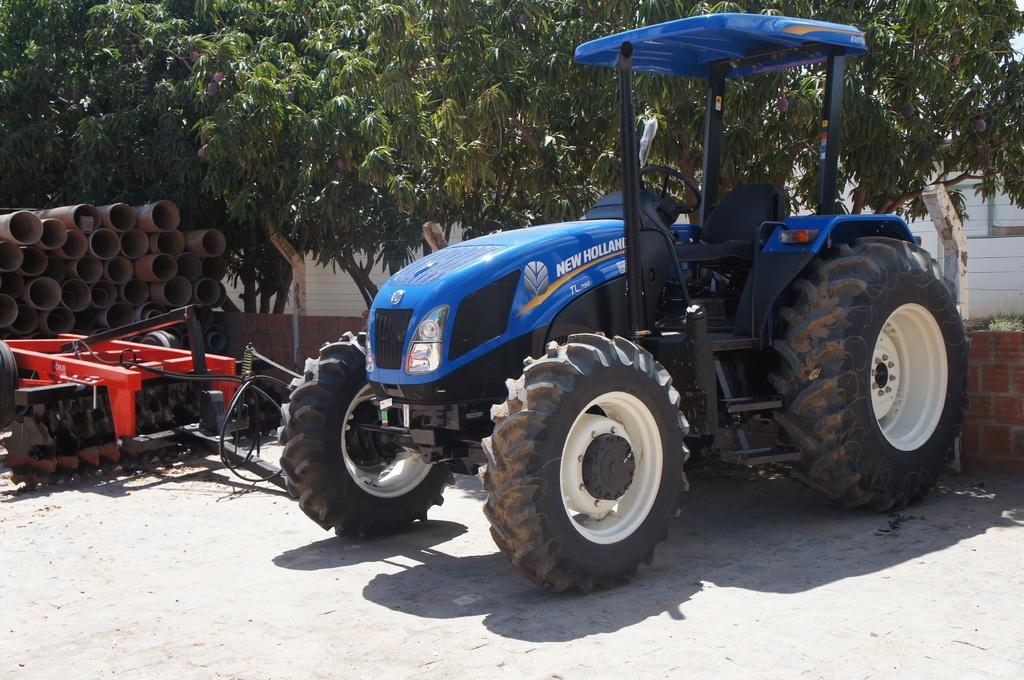What is the main object in the image? There is a tracker in the image. What is located near the tracker? There is a brick wall near the tracker. What other objects can be seen in the image? There are other objects in the image, but their specific details are not mentioned in the facts. What type of infrastructure is visible in the image? There are pipes in the image. What can be seen in the background of the image? There are trees with fruits in the background of the image. What type of advice does the grandfather give to the person holding the tracker in the image? There is no grandfather or person holding the tracker in the image; it only features a tracker, a brick wall, other objects, pipes, and trees with fruits in the background. --- Facts: 1. There is a person holding a book in the image. 2. The book has a blue cover. 3. The person is sitting on a chair. 4. There is a table in front of the person. 5. The table has a lamp on it. Absurd Topics: parrot, ocean, bicycle Conversation: What is the person in the image holding? The person in the image is holding a book. What color is the book's cover? The book has a blue cover. What is the person sitting on in the image? The person is sitting on a chair. What is in front of the person? There is a table in front of the person. What is on the table? The table has a lamp on it. Reasoning: Let's think step by step in order to produce the conversation. We start by identifying the main subject in the image, which is the person holding a book. Then, we describe the book's cover color. Next, we mention the person's seating arrangement, which is on a chair. We then describe the table in front of the person and what is on it, which is a lamp. Absurd Question/Answer: Can you see the parrot flying over the ocean in the image? There is no parrot or ocean present in the image; it only features a person holding a book with a blue cover, sitting on a chair, and a table with a lamp on it. 